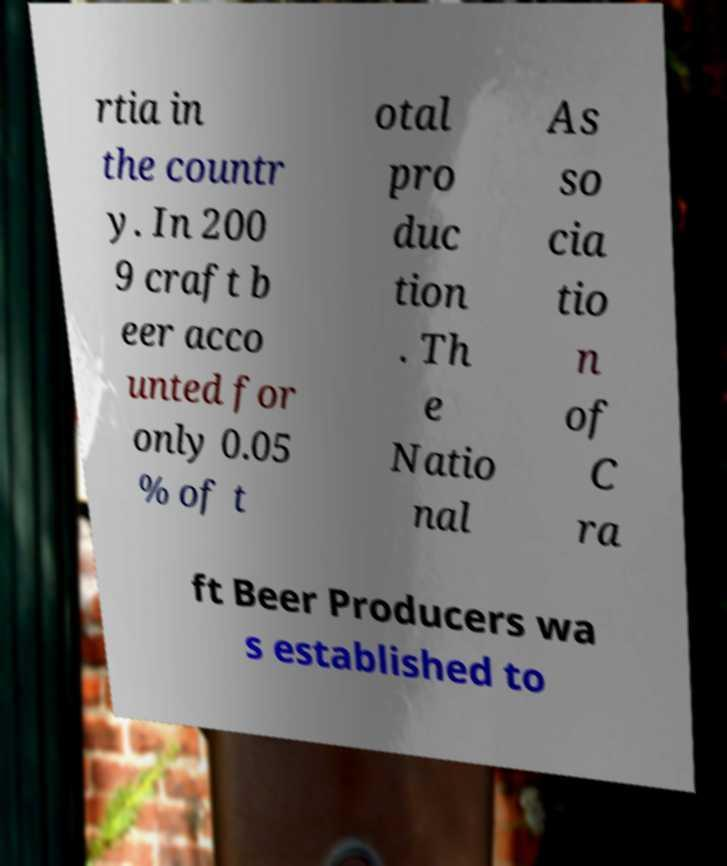Could you assist in decoding the text presented in this image and type it out clearly? rtia in the countr y. In 200 9 craft b eer acco unted for only 0.05 % of t otal pro duc tion . Th e Natio nal As so cia tio n of C ra ft Beer Producers wa s established to 